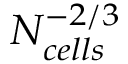Convert formula to latex. <formula><loc_0><loc_0><loc_500><loc_500>N _ { c e l l s } ^ { - 2 / 3 }</formula> 